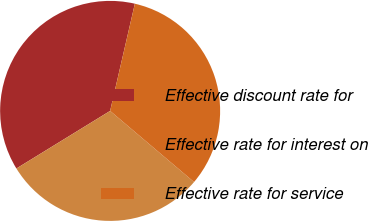Convert chart. <chart><loc_0><loc_0><loc_500><loc_500><pie_chart><fcel>Effective discount rate for<fcel>Effective rate for interest on<fcel>Effective rate for service<nl><fcel>37.38%<fcel>30.04%<fcel>32.58%<nl></chart> 